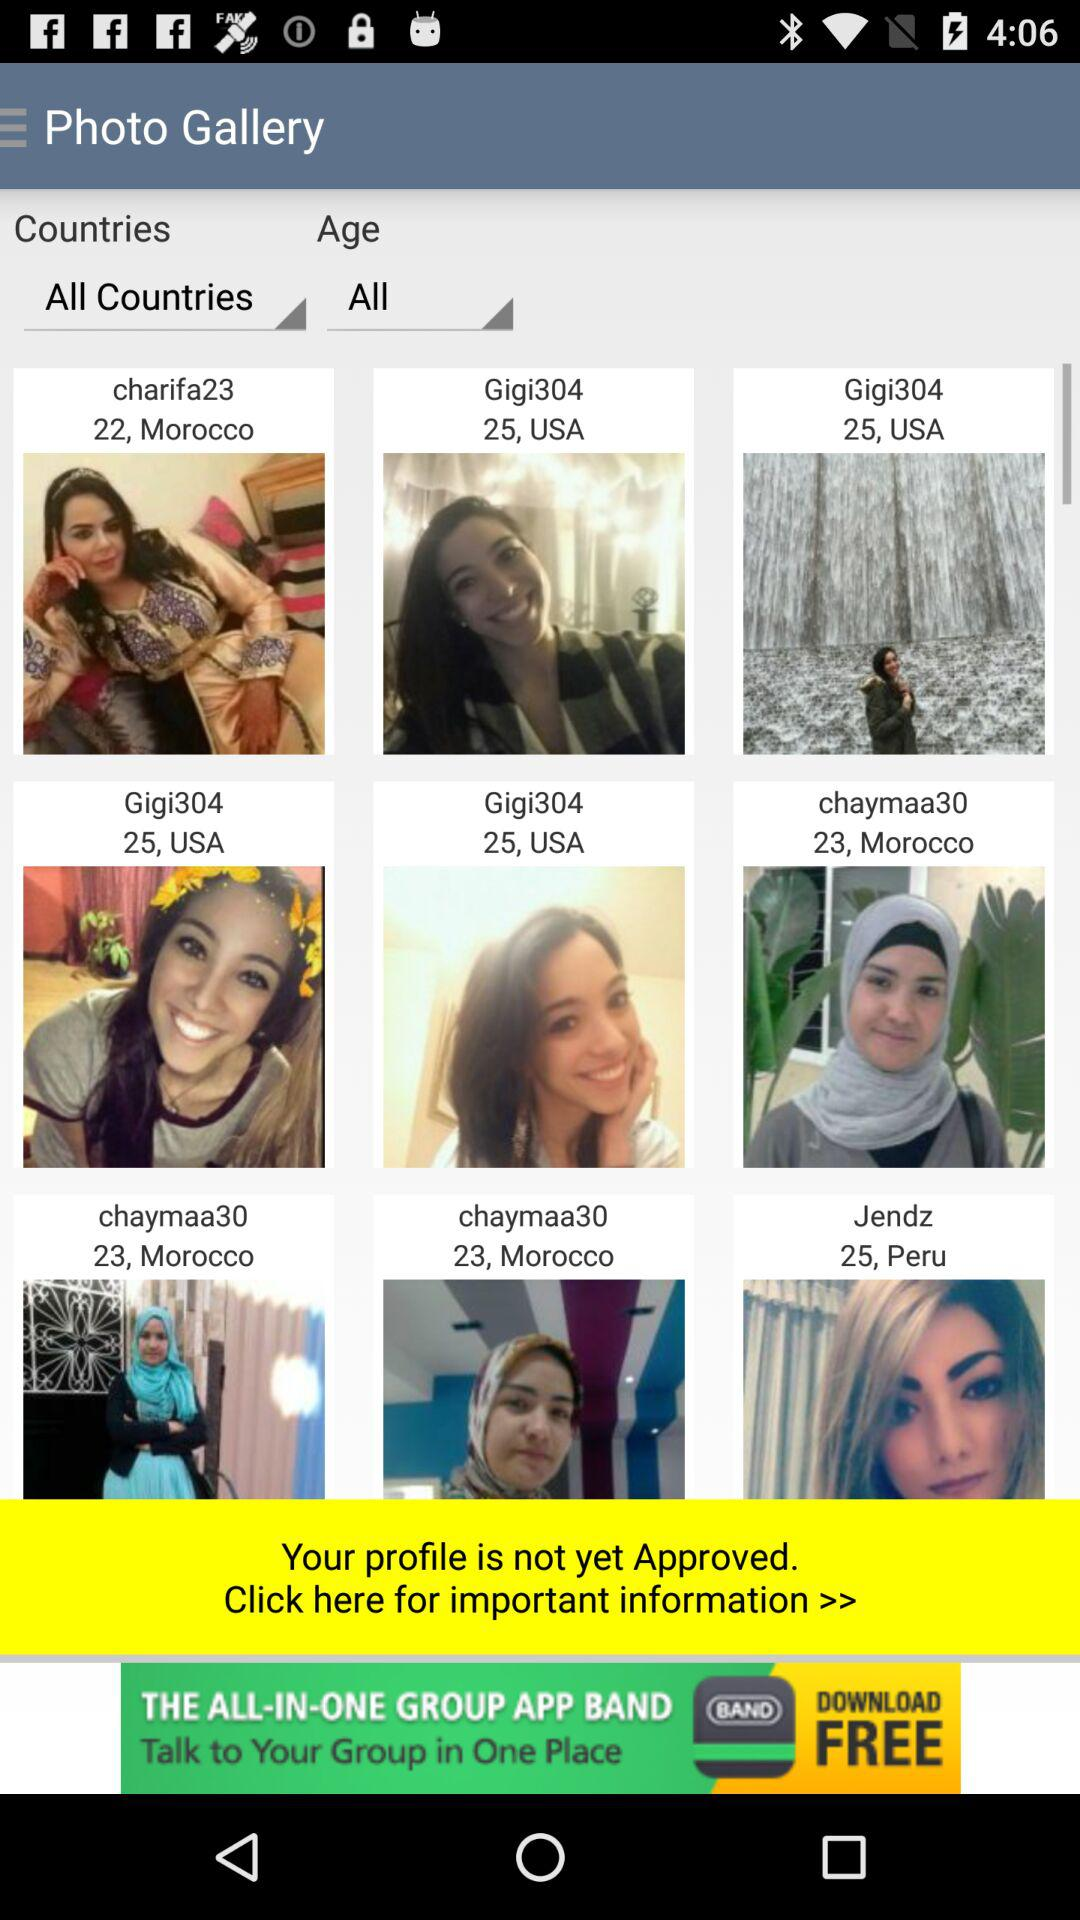Where is "charifa23" from? "charifa23" is from Morocco. 